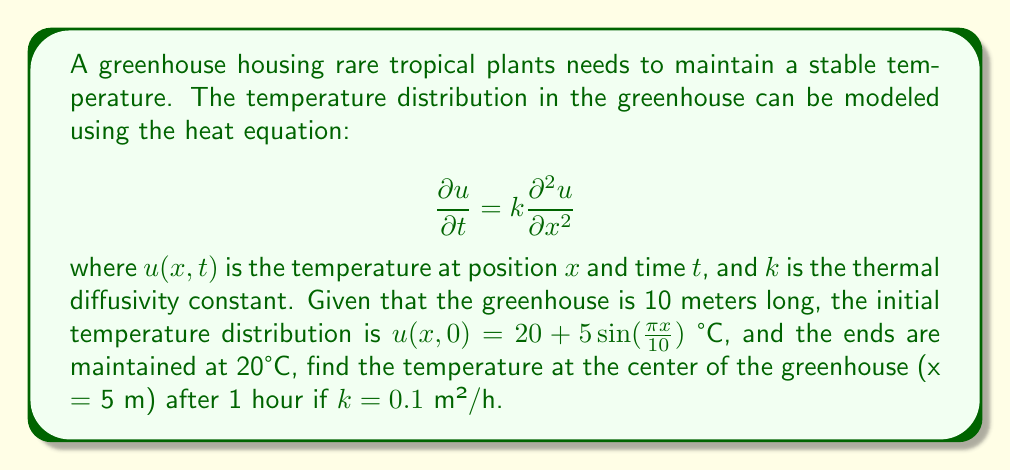Provide a solution to this math problem. To solve this problem, we'll use the method of separation of variables:

1) The general solution to the heat equation with these boundary conditions is:

   $$u(x,t) = 20 + \sum_{n=1}^{\infty} B_n \sin(\frac{n\pi x}{L})e^{-k(\frac{n\pi}{L})^2t}$$

   where $L = 10$ m is the length of the greenhouse.

2) From the initial condition, we can see that only the first term (n=1) of the series is non-zero:

   $$u(x,0) = 20 + 5\sin(\frac{\pi x}{10})$$

3) Therefore, $B_1 = 5$ and all other $B_n = 0$ for $n > 1$.

4) Our solution simplifies to:

   $$u(x,t) = 20 + 5\sin(\frac{\pi x}{10})e^{-k(\frac{\pi}{10})^2t}$$

5) At the center of the greenhouse, $x = 5$ m. After 1 hour, $t = 1$ h.

6) Substituting these values and $k = 0.1$ m²/h:

   $$u(5,1) = 20 + 5\sin(\frac{\pi \cdot 5}{10})e^{-0.1(\frac{\pi}{10})^2 \cdot 1}$$

7) Simplify:
   $$u(5,1) = 20 + 5 \cdot 1 \cdot e^{-0.1(\frac{\pi}{10})^2}$$
   $$u(5,1) = 20 + 5e^{-0.00987} \approx 24.95°C$$
Answer: 24.95°C 